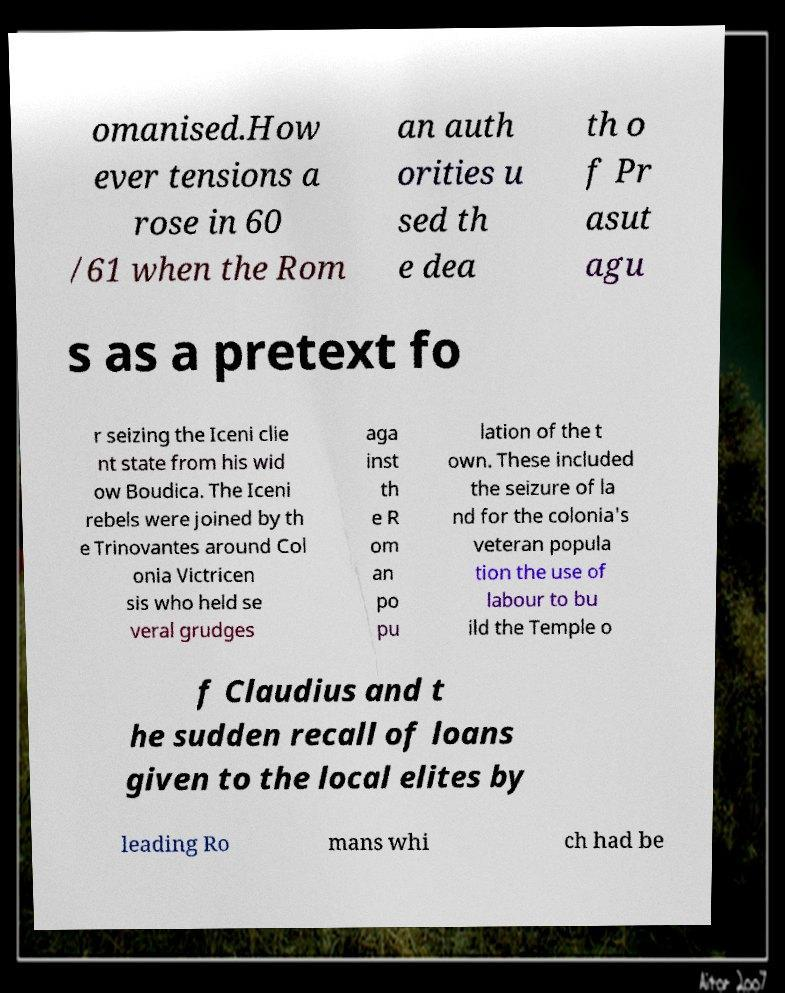Could you extract and type out the text from this image? omanised.How ever tensions a rose in 60 /61 when the Rom an auth orities u sed th e dea th o f Pr asut agu s as a pretext fo r seizing the Iceni clie nt state from his wid ow Boudica. The Iceni rebels were joined by th e Trinovantes around Col onia Victricen sis who held se veral grudges aga inst th e R om an po pu lation of the t own. These included the seizure of la nd for the colonia's veteran popula tion the use of labour to bu ild the Temple o f Claudius and t he sudden recall of loans given to the local elites by leading Ro mans whi ch had be 